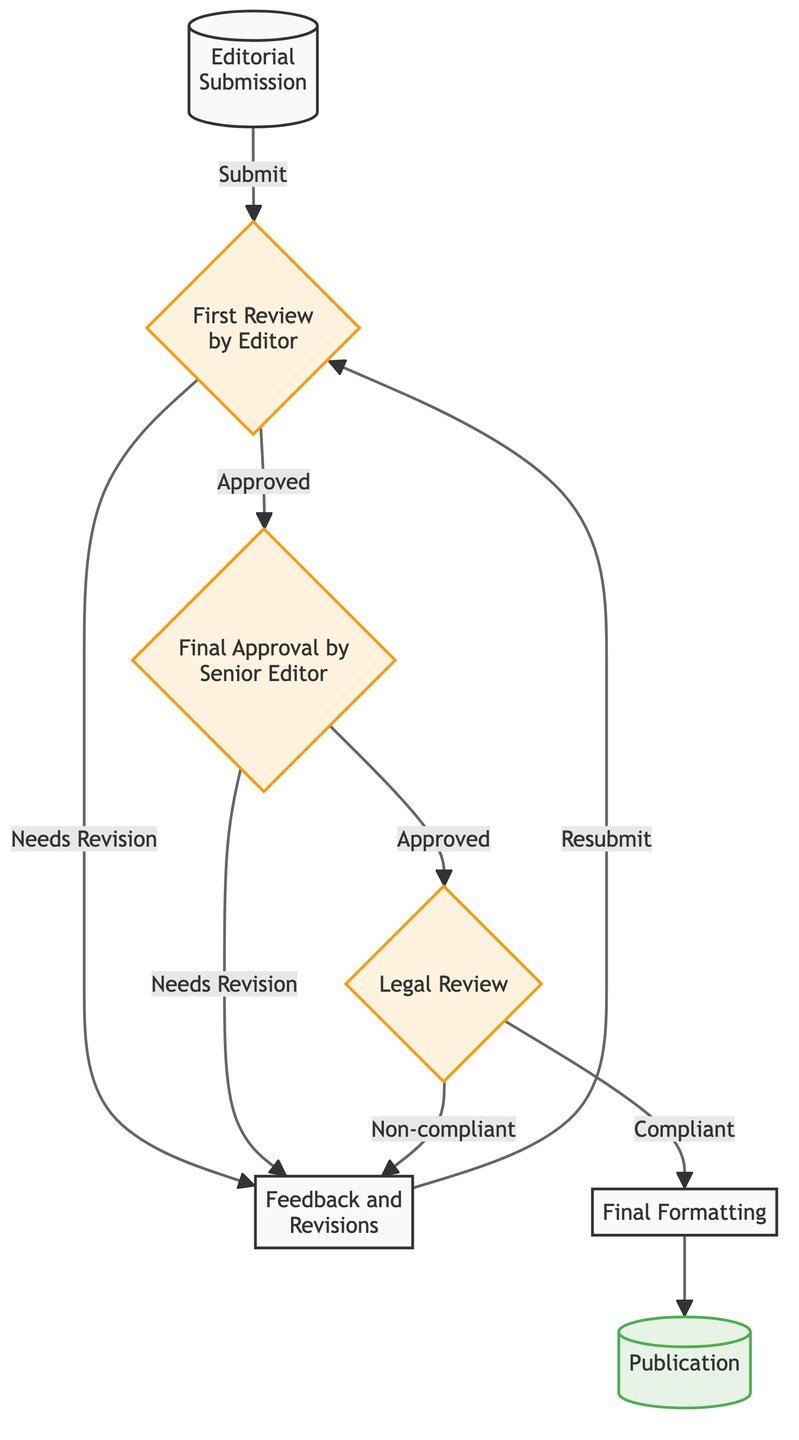What is the first step in the content approval workflow? The first step represented in the flow chart is "Editorial Submission," which is where the manuscript is initially submitted by the writer.
Answer: Editorial Submission How many main steps are there in the flowchart? The flowchart contains seven main steps, which include all the processes from submission to publication.
Answer: Seven What happens after the "First Review by Editor"? After the "First Review by Editor," if the content needs revision, it flows to "Feedback and Revisions." If approved, it proceeds to "Final Approval by Senior Editor."
Answer: Feedback and Revisions or Final Approval by Senior Editor What node represents the final output of the workflow? The final output of the workflow is represented by the node "Publication," which indicates the content is published.
Answer: Publication What step follows "Legal Review" if the content is compliant? If the content is compliant after "Legal Review," it flows to "Final Formatting," which prepares the content for print.
Answer: Final Formatting What happens if the content is found to be non-compliant during the "Legal Review"? If the content is found to be non-compliant during the "Legal Review," the workflow directs back to "Feedback and Revisions" for necessary changes.
Answer: Feedback and Revisions What is the decision point after "Final Approval by Senior Editor"? The decision point after "Final Approval by Senior Editor" allows for two outcomes: the content can either be sent back to "Feedback and Revisions" if it needs revision or progress to "Legal Review" if approved.
Answer: Needs Revision or Legal Review How does the flowchart indicate the feedback mechanism in the process? The flowchart indicates the feedback mechanism through arrows pointing from "First Review by Editor" to "Feedback and Revisions," showing that revisions can occur after editor reviews.
Answer: Arrows from First Review by Editor to Feedback and Revisions 